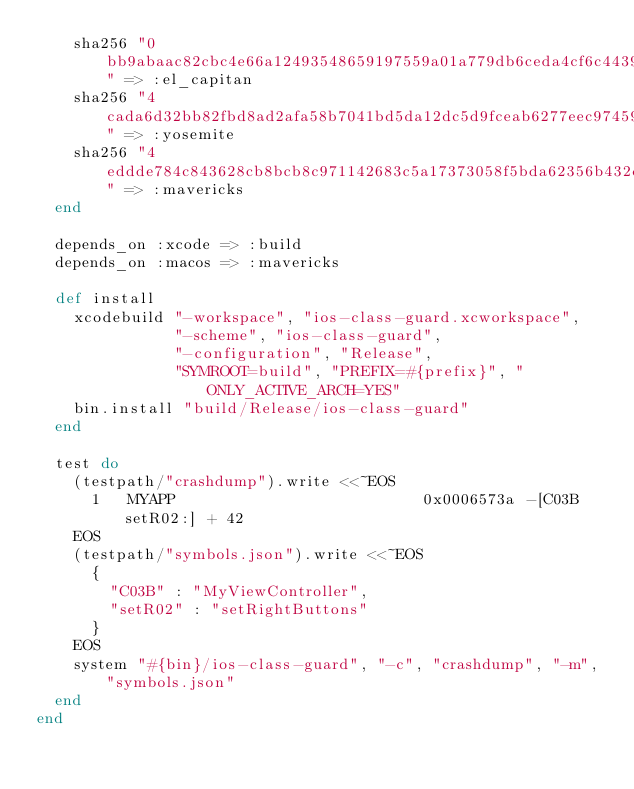<code> <loc_0><loc_0><loc_500><loc_500><_Ruby_>    sha256 "0bb9abaac82cbc4e66a12493548659197559a01a779db6ceda4cf6c4439ea0bb" => :el_capitan
    sha256 "4cada6d32bb82fbd8ad2afa58b7041bd5da12dc5d9fceab6277eec97459a2d33" => :yosemite
    sha256 "4eddde784c843628cb8bcb8c971142683c5a17373058f5bda62356b432dec00a" => :mavericks
  end

  depends_on :xcode => :build
  depends_on :macos => :mavericks

  def install
    xcodebuild "-workspace", "ios-class-guard.xcworkspace",
               "-scheme", "ios-class-guard",
               "-configuration", "Release",
               "SYMROOT=build", "PREFIX=#{prefix}", "ONLY_ACTIVE_ARCH=YES"
    bin.install "build/Release/ios-class-guard"
  end

  test do
    (testpath/"crashdump").write <<~EOS
      1   MYAPP                           0x0006573a -[C03B setR02:] + 42
    EOS
    (testpath/"symbols.json").write <<~EOS
      {
        "C03B" : "MyViewController",
        "setR02" : "setRightButtons"
      }
    EOS
    system "#{bin}/ios-class-guard", "-c", "crashdump", "-m", "symbols.json"
  end
end
</code> 